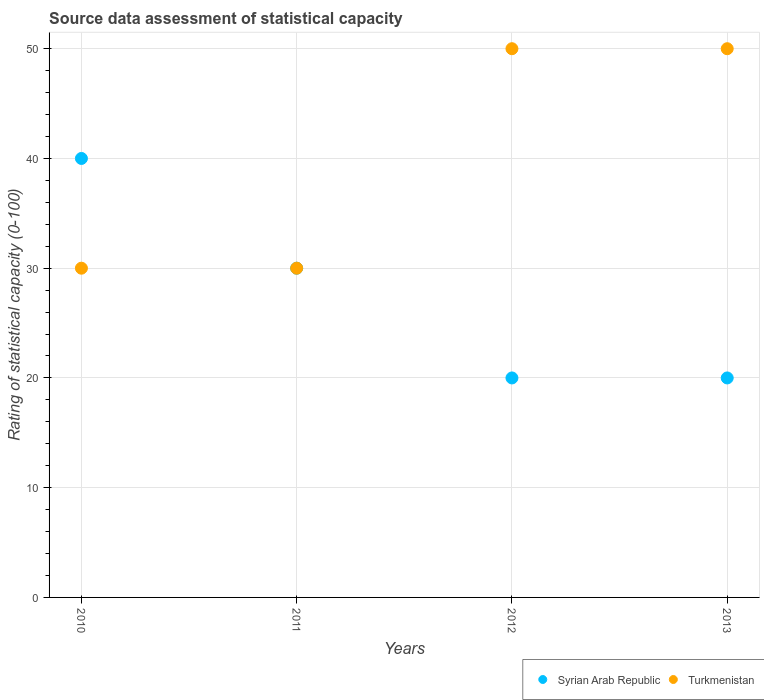How many different coloured dotlines are there?
Keep it short and to the point. 2. Is the number of dotlines equal to the number of legend labels?
Your response must be concise. Yes. What is the rating of statistical capacity in Syrian Arab Republic in 2012?
Your answer should be very brief. 20. Across all years, what is the maximum rating of statistical capacity in Turkmenistan?
Provide a succinct answer. 50. Across all years, what is the minimum rating of statistical capacity in Syrian Arab Republic?
Make the answer very short. 20. In which year was the rating of statistical capacity in Turkmenistan maximum?
Your response must be concise. 2012. In which year was the rating of statistical capacity in Turkmenistan minimum?
Your answer should be very brief. 2010. What is the total rating of statistical capacity in Turkmenistan in the graph?
Your response must be concise. 160. What is the difference between the rating of statistical capacity in Turkmenistan in 2011 and that in 2013?
Your response must be concise. -20. What is the difference between the rating of statistical capacity in Turkmenistan in 2013 and the rating of statistical capacity in Syrian Arab Republic in 2012?
Your response must be concise. 30. What is the average rating of statistical capacity in Syrian Arab Republic per year?
Ensure brevity in your answer.  27.5. In the year 2013, what is the difference between the rating of statistical capacity in Turkmenistan and rating of statistical capacity in Syrian Arab Republic?
Make the answer very short. 30. In how many years, is the rating of statistical capacity in Turkmenistan greater than 4?
Ensure brevity in your answer.  4. What is the ratio of the rating of statistical capacity in Turkmenistan in 2011 to that in 2012?
Your answer should be very brief. 0.6. Is the rating of statistical capacity in Turkmenistan in 2010 less than that in 2011?
Keep it short and to the point. No. Is the difference between the rating of statistical capacity in Turkmenistan in 2011 and 2013 greater than the difference between the rating of statistical capacity in Syrian Arab Republic in 2011 and 2013?
Your answer should be compact. No. What is the difference between the highest and the lowest rating of statistical capacity in Turkmenistan?
Keep it short and to the point. 20. Is the sum of the rating of statistical capacity in Syrian Arab Republic in 2012 and 2013 greater than the maximum rating of statistical capacity in Turkmenistan across all years?
Make the answer very short. No. Does the rating of statistical capacity in Turkmenistan monotonically increase over the years?
Your answer should be very brief. No. How many dotlines are there?
Your answer should be compact. 2. Are the values on the major ticks of Y-axis written in scientific E-notation?
Offer a terse response. No. Does the graph contain any zero values?
Offer a very short reply. No. Where does the legend appear in the graph?
Your answer should be compact. Bottom right. How many legend labels are there?
Make the answer very short. 2. What is the title of the graph?
Offer a terse response. Source data assessment of statistical capacity. Does "Mexico" appear as one of the legend labels in the graph?
Provide a succinct answer. No. What is the label or title of the Y-axis?
Your answer should be very brief. Rating of statistical capacity (0-100). What is the Rating of statistical capacity (0-100) of Syrian Arab Republic in 2010?
Make the answer very short. 40. What is the Rating of statistical capacity (0-100) in Turkmenistan in 2010?
Offer a very short reply. 30. What is the Rating of statistical capacity (0-100) in Syrian Arab Republic in 2011?
Your answer should be very brief. 30. What is the Rating of statistical capacity (0-100) of Syrian Arab Republic in 2013?
Your answer should be compact. 20. Across all years, what is the minimum Rating of statistical capacity (0-100) in Syrian Arab Republic?
Your answer should be very brief. 20. Across all years, what is the minimum Rating of statistical capacity (0-100) of Turkmenistan?
Your response must be concise. 30. What is the total Rating of statistical capacity (0-100) in Syrian Arab Republic in the graph?
Provide a short and direct response. 110. What is the total Rating of statistical capacity (0-100) in Turkmenistan in the graph?
Provide a short and direct response. 160. What is the difference between the Rating of statistical capacity (0-100) of Syrian Arab Republic in 2010 and that in 2011?
Give a very brief answer. 10. What is the difference between the Rating of statistical capacity (0-100) of Syrian Arab Republic in 2010 and that in 2012?
Give a very brief answer. 20. What is the difference between the Rating of statistical capacity (0-100) in Syrian Arab Republic in 2010 and that in 2013?
Provide a short and direct response. 20. What is the difference between the Rating of statistical capacity (0-100) in Turkmenistan in 2010 and that in 2013?
Make the answer very short. -20. What is the difference between the Rating of statistical capacity (0-100) of Syrian Arab Republic in 2011 and that in 2012?
Make the answer very short. 10. What is the difference between the Rating of statistical capacity (0-100) of Turkmenistan in 2011 and that in 2013?
Make the answer very short. -20. What is the difference between the Rating of statistical capacity (0-100) in Turkmenistan in 2012 and that in 2013?
Your response must be concise. 0. What is the difference between the Rating of statistical capacity (0-100) of Syrian Arab Republic in 2010 and the Rating of statistical capacity (0-100) of Turkmenistan in 2011?
Keep it short and to the point. 10. What is the difference between the Rating of statistical capacity (0-100) of Syrian Arab Republic in 2010 and the Rating of statistical capacity (0-100) of Turkmenistan in 2013?
Your response must be concise. -10. What is the difference between the Rating of statistical capacity (0-100) in Syrian Arab Republic in 2011 and the Rating of statistical capacity (0-100) in Turkmenistan in 2013?
Provide a short and direct response. -20. What is the difference between the Rating of statistical capacity (0-100) of Syrian Arab Republic in 2012 and the Rating of statistical capacity (0-100) of Turkmenistan in 2013?
Your answer should be very brief. -30. In the year 2013, what is the difference between the Rating of statistical capacity (0-100) of Syrian Arab Republic and Rating of statistical capacity (0-100) of Turkmenistan?
Your response must be concise. -30. What is the ratio of the Rating of statistical capacity (0-100) in Syrian Arab Republic in 2010 to that in 2012?
Your response must be concise. 2. What is the ratio of the Rating of statistical capacity (0-100) in Turkmenistan in 2010 to that in 2013?
Give a very brief answer. 0.6. What is the ratio of the Rating of statistical capacity (0-100) in Syrian Arab Republic in 2011 to that in 2012?
Offer a very short reply. 1.5. What is the ratio of the Rating of statistical capacity (0-100) in Turkmenistan in 2011 to that in 2013?
Offer a terse response. 0.6. What is the ratio of the Rating of statistical capacity (0-100) in Syrian Arab Republic in 2012 to that in 2013?
Your response must be concise. 1. What is the difference between the highest and the lowest Rating of statistical capacity (0-100) in Syrian Arab Republic?
Keep it short and to the point. 20. What is the difference between the highest and the lowest Rating of statistical capacity (0-100) in Turkmenistan?
Your answer should be compact. 20. 